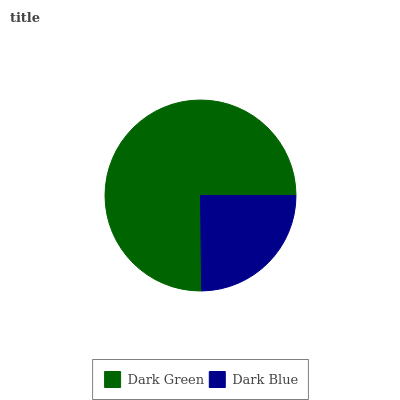Is Dark Blue the minimum?
Answer yes or no. Yes. Is Dark Green the maximum?
Answer yes or no. Yes. Is Dark Blue the maximum?
Answer yes or no. No. Is Dark Green greater than Dark Blue?
Answer yes or no. Yes. Is Dark Blue less than Dark Green?
Answer yes or no. Yes. Is Dark Blue greater than Dark Green?
Answer yes or no. No. Is Dark Green less than Dark Blue?
Answer yes or no. No. Is Dark Green the high median?
Answer yes or no. Yes. Is Dark Blue the low median?
Answer yes or no. Yes. Is Dark Blue the high median?
Answer yes or no. No. Is Dark Green the low median?
Answer yes or no. No. 